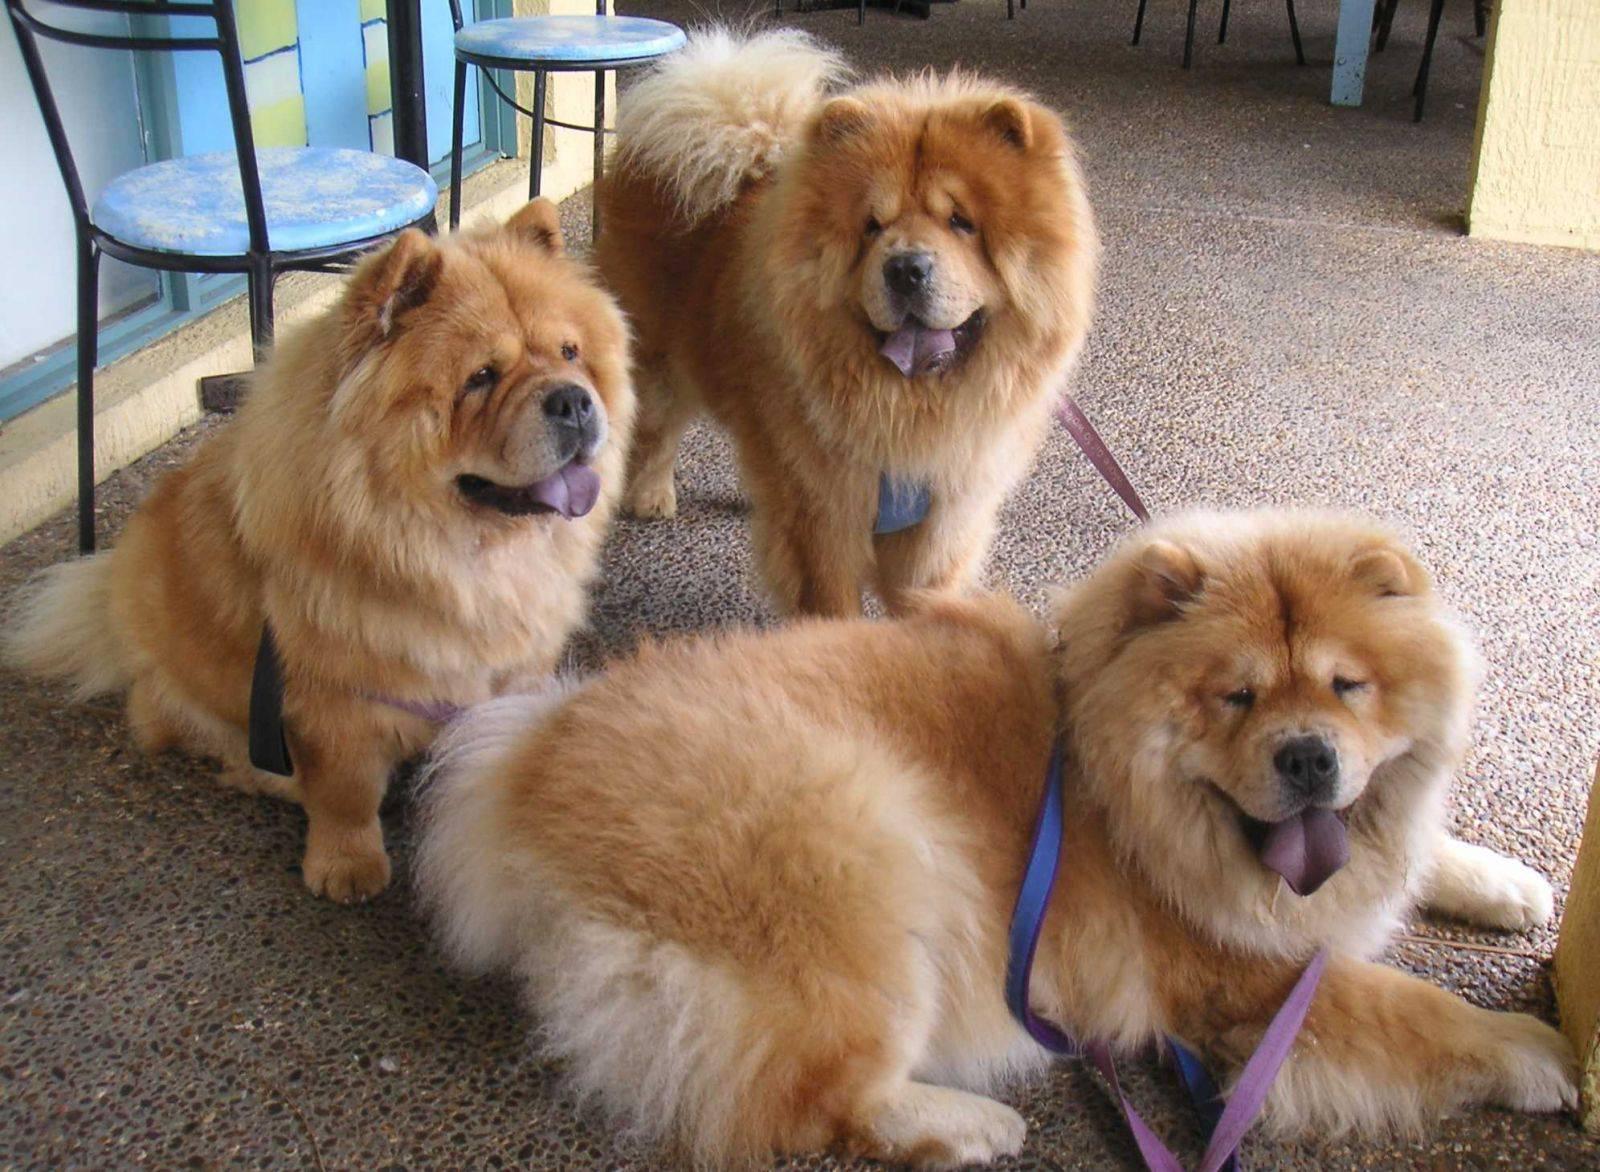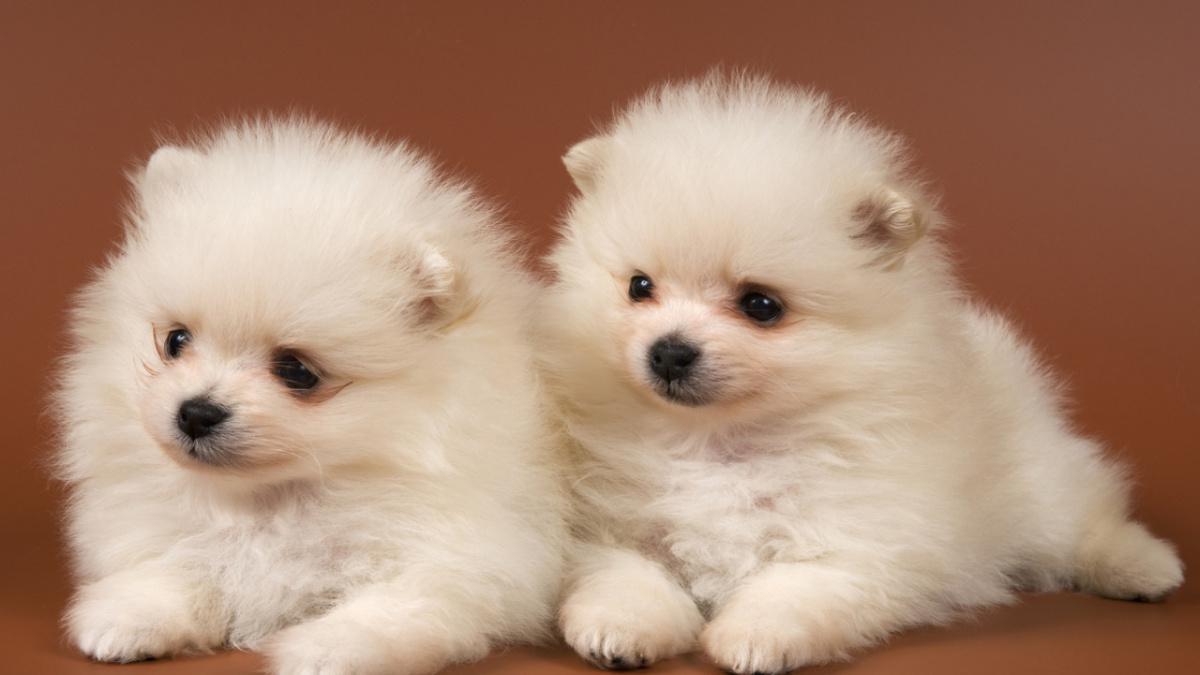The first image is the image on the left, the second image is the image on the right. Given the left and right images, does the statement "One of the images contains at least three dogs." hold true? Answer yes or no. Yes. 